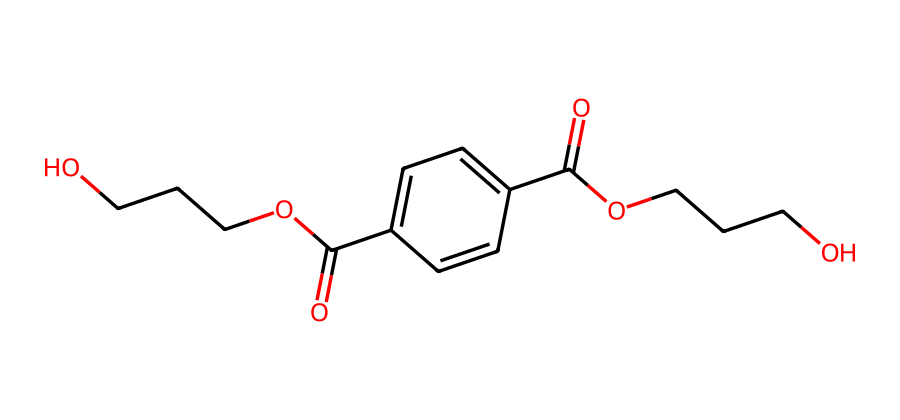What is the primary functional group in this molecule? The SMILES representation indicates a carboxylic acid (C(=O)O) as well as ester groups (OCCCO). The presence of both indicates the molecule is an esterification product. However, since the question asks for the primary functional group, we can identify that the most prominent functional group is the carboxylic acid, based on its distinct appearance in the SMILES.
Answer: carboxylic acid How many carbon atoms are present in this structure? By analyzing the SMILES representation, we can count the carbon atoms explicitly mentioned. There are indications of carbon chains and two carbonyl groups. Counting them gives a total of 10 carbon atoms in the structure.
Answer: 10 What type of polymer is represented by this chemical structure? The chemical structure represents a linear polymer known as a polyester due to the presence of ester linkages combined with aromatic rings (from the phenol) and aliphatic portions. This configuration is typical of polyesters, particularly with PET.
Answer: polyester What is the degree of polymerization indicated by this structure? The degree of polymerization indicates how many repeating units are present. While the molecule shows characteristics of a polymer, to determine the degree, we look at the number of repeating units inferred from the structure. This representation generally suggests a degree of polymerization of around 2 due to the terminal groups present.
Answer: 2 Which structural feature contributes to the rigidity of this polymer? The presence of aromatic rings (the benzene moiety) in the structure contributes to rigidity through π-π stacking interactions and adds stability. This structural feature prevents flexible movement of polymer chains, making the material more rigid.
Answer: aromatic rings Does the presence of ester bonds affect the thermal properties of this polymer? Yes, the presence of ester bonds in the polymer affects its thermal properties, mainly causing it to have a higher melting point and better thermal stability compared to other types of polymers like polyolefins. This is due to more significant interaction between polymer chains.
Answer: Yes 